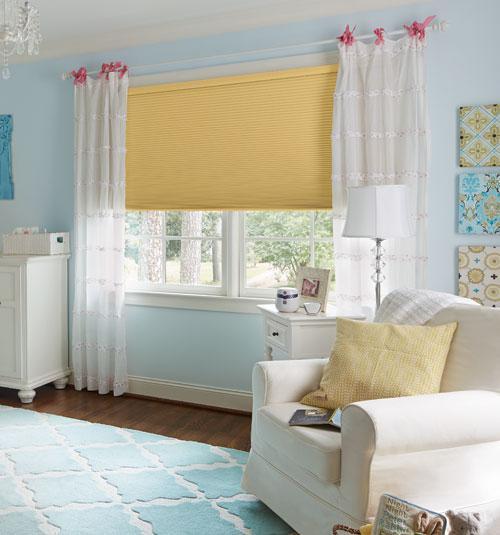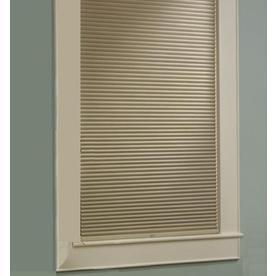The first image is the image on the left, the second image is the image on the right. Analyze the images presented: Is the assertion "The left image includes at least two white-framed rectangular windows with colored shades and no drapes, behind beige furniture piled with pillows." valid? Answer yes or no. No. 